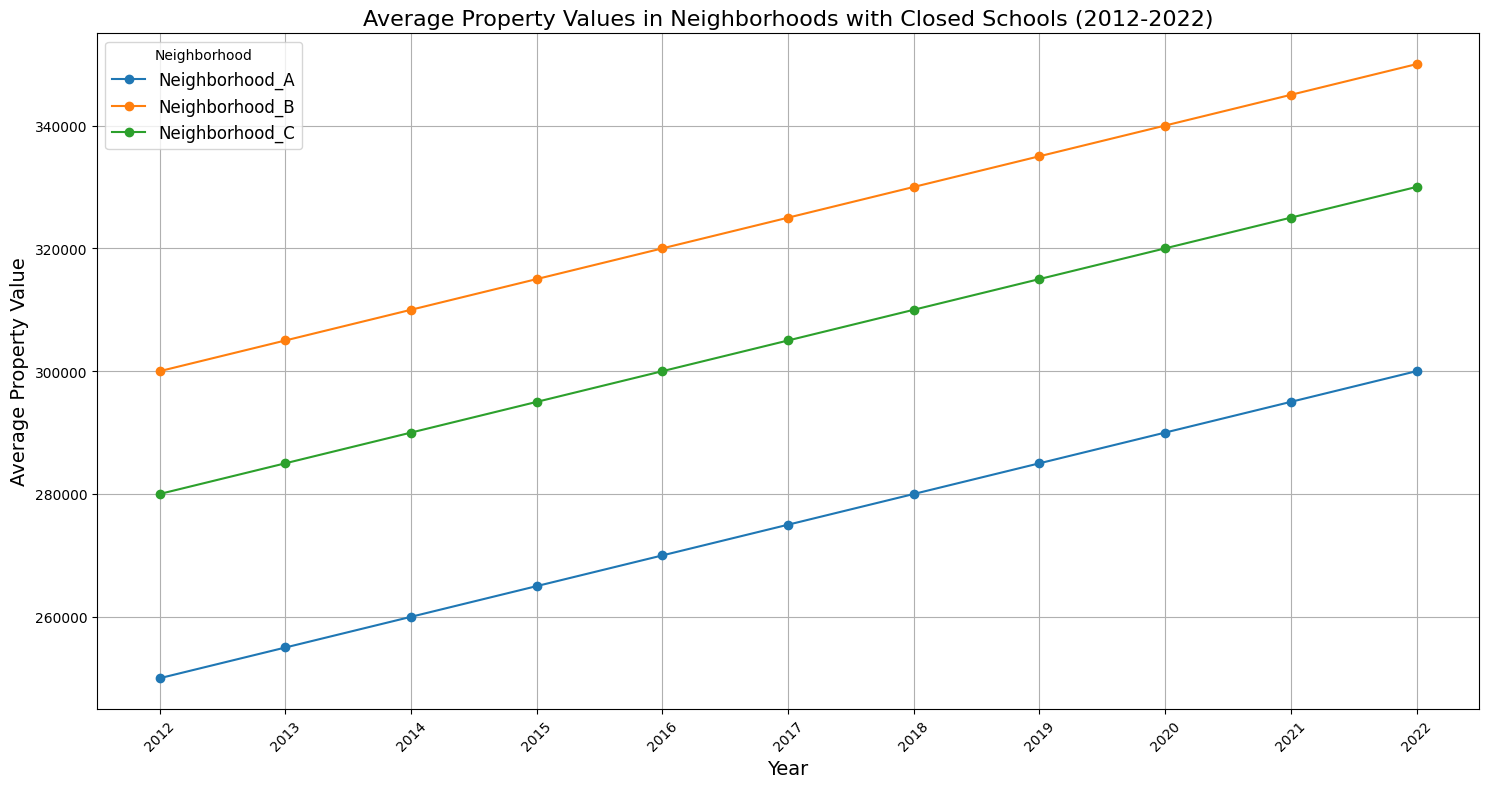What's the trend in average property values for Neighborhood B from 2012 to 2022? The trend can be observed by looking at the line representing Neighborhood B in the plot. Starting at $300,000 in 2012, the values steadily increase each year, reaching $350,000 in 2022.
Answer: The trend is an upward trajectory Which neighborhood had the highest average property value in 2022? By comparing the endpoints of the lines in 2022, Neighborhood B has the highest endpoint at $350,000.
Answer: Neighborhood B Between which years did Neighborhood A see the largest increase in average property value? Observe the line for Neighborhood A and look for the steepest part. The sharpest increase is from 2021 to 2022, with values rising from $295,000 to $300,000.
Answer: 2021 to 2022 Compare the average property value of Neighborhood C to Neighborhood A in 2015. Which is higher and by how much? Locate the points for Neighborhood A and Neighborhood C in 2015 on the plot. Neighborhood A is at $265,000, and Neighborhood C is at $295,000. Subtract to find the difference: $295,000 - $265,000 = $30,000.
Answer: Neighborhood C by $30,000 What is the average property value difference between Neighborhoods B and A over the decade? Sum the differences between Neighborhood B and A for each year from 2012 to 2022: (50,000 + 50,000 + 50,000 + 50,000 + 50,000 + 50,000 + 50,000 + 50,000 + 50,000 + 50,000 + 50,000) = 550,000. Divide by number of years (11): 550,000/11 = $50,000.
Answer: $50,000 Which neighborhood shows the least variation in property values over the decade? Observe the plots for each neighborhood, looking at how much each line deviates from a straight line. Neighborhood C maintains a relatively consistent slope and does not show large fluctuations.
Answer: Neighborhood C In what year did all neighborhoods have their minimum average property values? Identify the year where all lines have their lowest points, which is at the beginning of the chart in 2012.
Answer: 2012 How much did the average property value in Neighborhood C increase annually on average? Find the difference between the values of 2022 and 2012 for Neighborhood C: $330,000 - $280,000 = $50,000. Divide by the number of years (10): $50,000/10 = $5,000 per year.
Answer: $5,000 per year Did Neighborhood A ever surpass Neighborhood B in average property value during the decade? Trace both lines representing Neighborhoods A and B throughout the plot. Neighborhood A's line is always below Neighborhood B's line, indicating it never surpassed.
Answer: No What is the most notable feature of the property value trends in Neighborhood C? The line for Neighborhood C shows a steady, consistent increase each year with no sharp rises or falls, indicating very stable growth.
Answer: Steady, consistent increase 